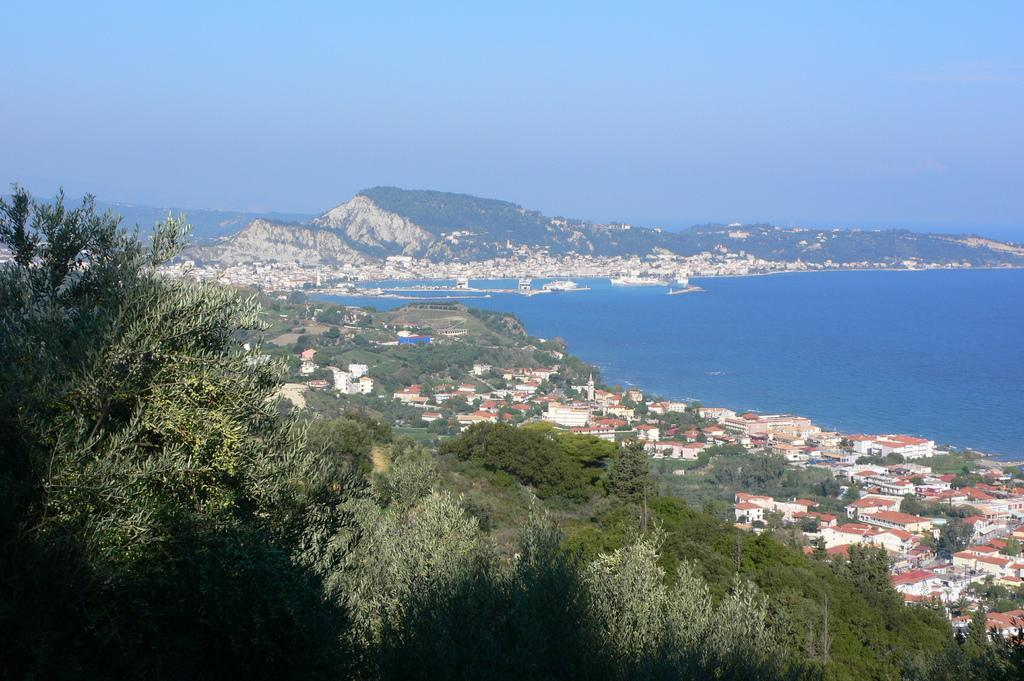What type of vegetation can be seen in the image? There are trees in the image. What type of structures are visible in the image? There are houses in the image. What body of water is present on the right side of the image? There is an ocean on the right side of the image. What geographical feature can be seen in the background of the image? There is a hill visible in the background of the image. What part of the natural environment is visible in the background of the image? The sky is visible in the background of the image. Where is the mailbox located in the image? There is no mailbox present in the image. What time of day is it in the image, considering the presence of the afternoon? The provided facts do not mention the time of day or the presence of the afternoon, so it cannot be determined from the image. 